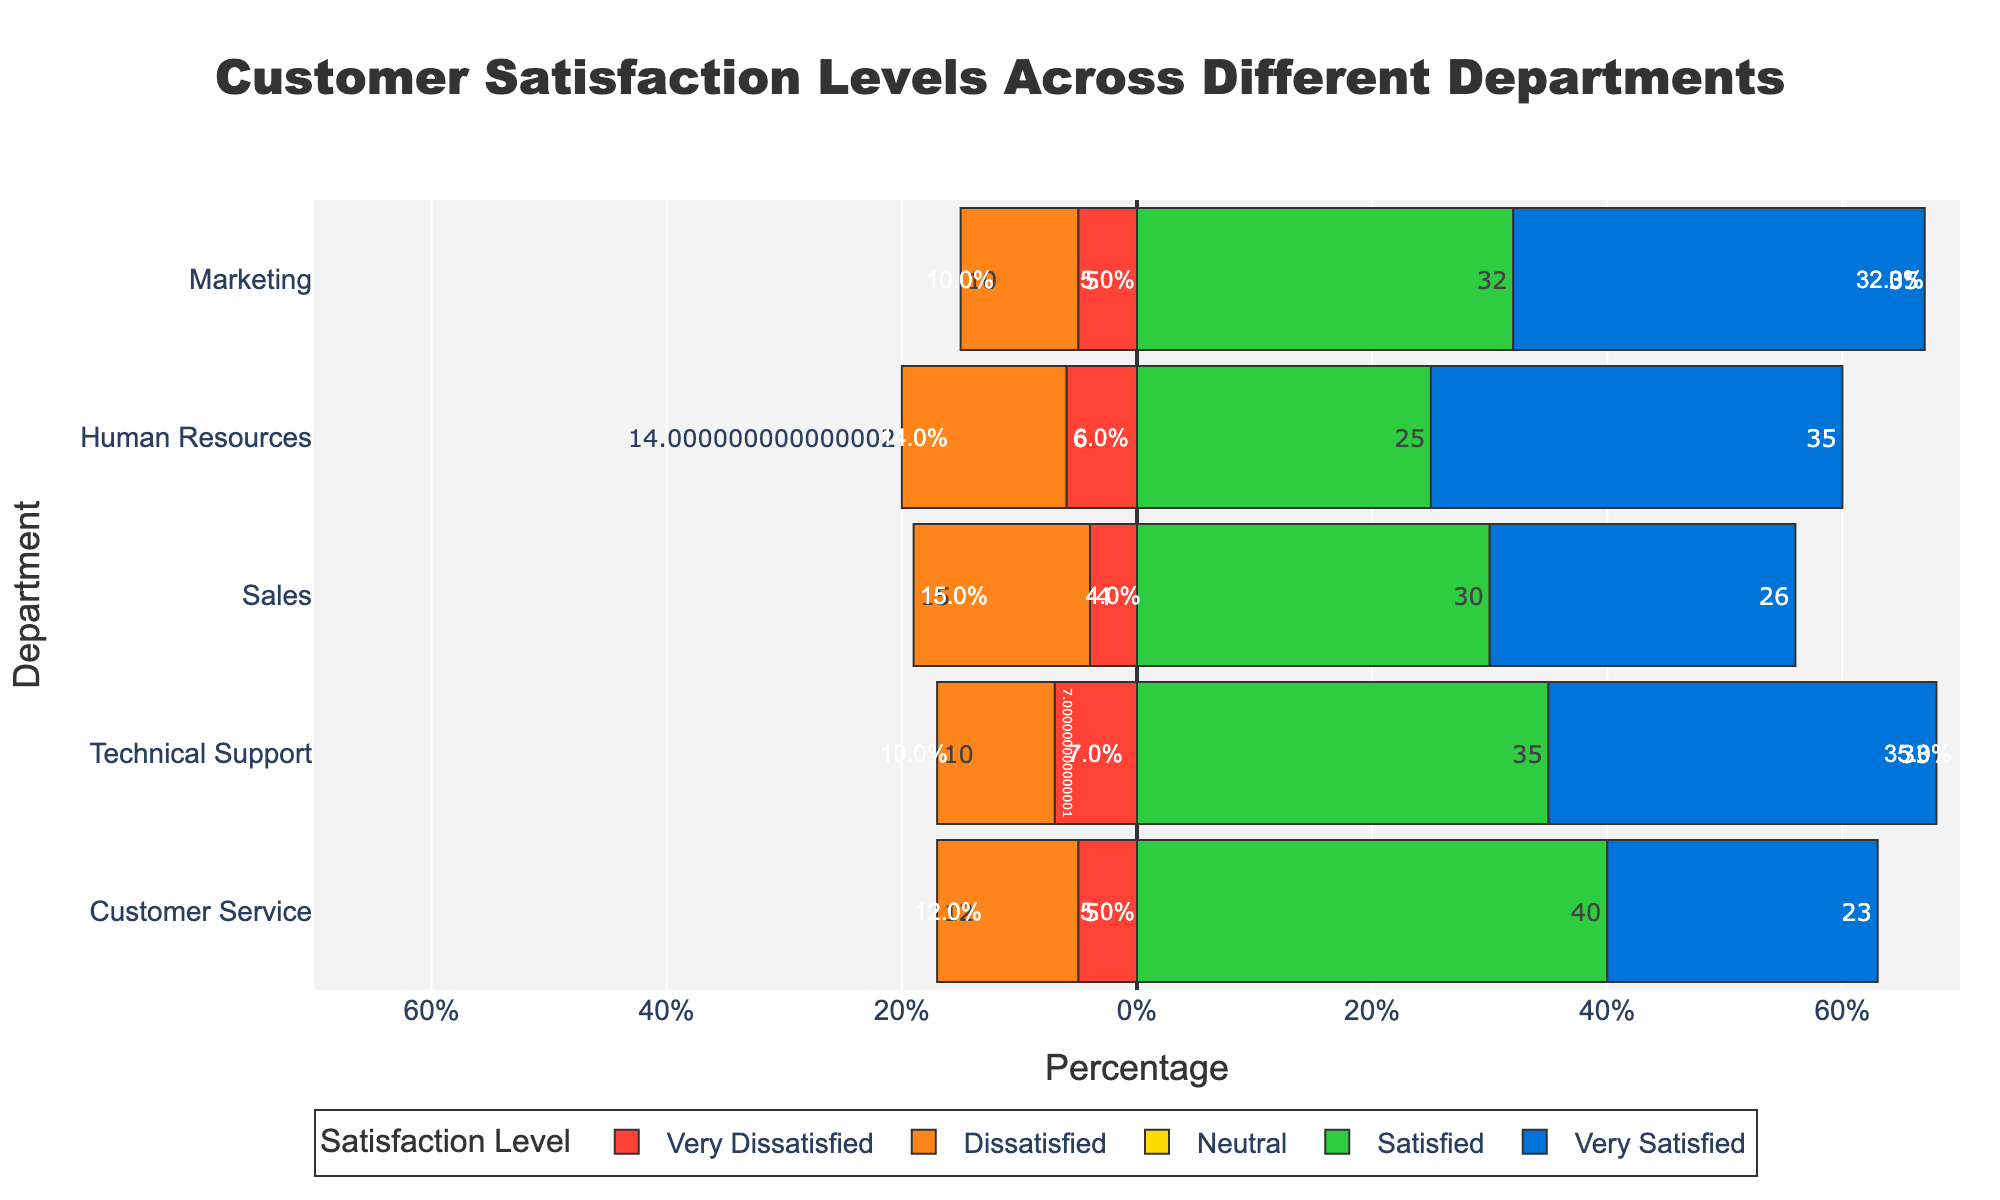What's the overall satisfaction rate for the Marketing department (Satisfied + Very Satisfied)? The Marketing department has 32% Satisfied and 35% Very Satisfied customers. Summing these percentages gives the overall satisfaction rate: 32% + 35% = 67%.
Answer: 67% Which department has the highest percentage of Very Satisfied customers? Looking at the Very Satisfied categories, the Human Resources department has the highest percentage at 35%. Other departments have lower percentages.
Answer: Human Resources What is the percentage difference between Satisfied and Dissatisfied customers in the Sales department? The Sales department has 30% Satisfied and 15% Dissatisfied customers. The percentage difference is 30% - 15% = 15%.
Answer: 15% Which department shows the highest percentage of Very Dissatisfied customers? The Technical Support department shows the highest percentage of Very Dissatisfied customers at 7%. Other departments have lower percentages.
Answer: Technical Support What is the total percentage of Neutral opinions in all departments combined? Summing up the Neutral percentages: 20% (Customer Service) + 15% (Technical Support) + 25% (Sales) + 20% (Human Resources) + 18% (Marketing) = 98%.
Answer: 98% Which department has the smallest proportion of Satisfied customers relative to dissatisfied ones (Very Dissatisfied + Dissatisfied)? For each department:
- Customer Service: 40% vs 17%
- Technical Support: 35% vs 17%
- Sales: 30% vs 19%
- Human Resources: 25% vs 20%
- Marketing: 32% vs 15%
The Human Resources department has a relatively smaller proportion: 25% Satisfied to 20% Dissatisfied.
Answer: Human Resources Among the departments, which one has the closest balance between Satisfied and Dissatisfied (Very Dissatisfied + Dissatisfied) customers? Examining the balance:
- Customer Service: 40% Satisfied vs 17% Dissatisfied
- Technical Support: 35% Satisfied vs 17% Dissatisfied
- Sales: 30% Satisfied vs 19% Dissatisfied
- Human Resources: 25% Satisfied vs 20% Dissatisfied
- Marketing: 32% Satisfied vs 15% Dissatisfied
The Human Resources department shows the closest balance with 25% Satisfied vs 20% Dissatisfied.
Answer: Human Resources What is the difference in the percentage of Neutral customers between Customer Service and Marketing? Customer Service has 20% Neutral customers, while Marketing has 18%. The difference is 20% - 18% = 2%.
Answer: 2% How does the Neutral percentage in Technical Support compare to that in the Sales department? The Neutral percentage in Technical Support is 15%, while in Sales it is 25%. Comparing them, Sales has a higher Neutral percentage.
Answer: Sales Which department has the highest total percentage of dissatisfied (Very Dissatisfied + Dissatisfied) customers? Summing the Very Dissatisfied and Dissatisfied categories:
- Customer Service: 5% + 12% = 17%
- Technical Support: 7% + 10% = 17%
- Sales: 4% + 15% = 19%
- Human Resources: 6% + 14% = 20%
- Marketing: 5% + 10% = 15%
The Human Resources department has the highest total, with 20% dissatisfied customers.
Answer: Human Resources 